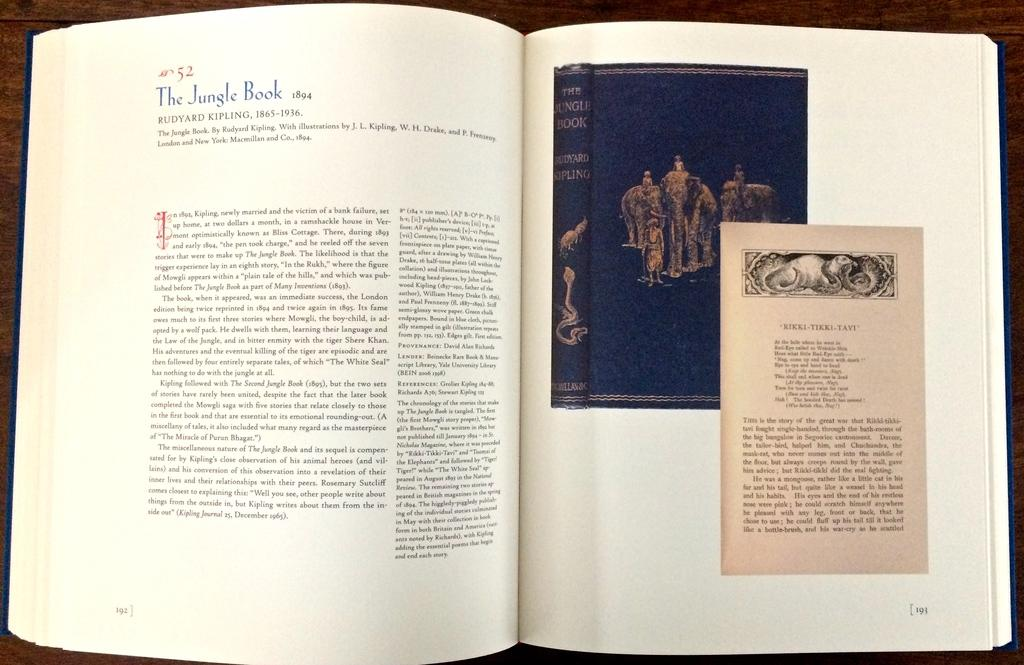<image>
Present a compact description of the photo's key features. A reference book shows a picture of an old copy of The Jungle Book. 